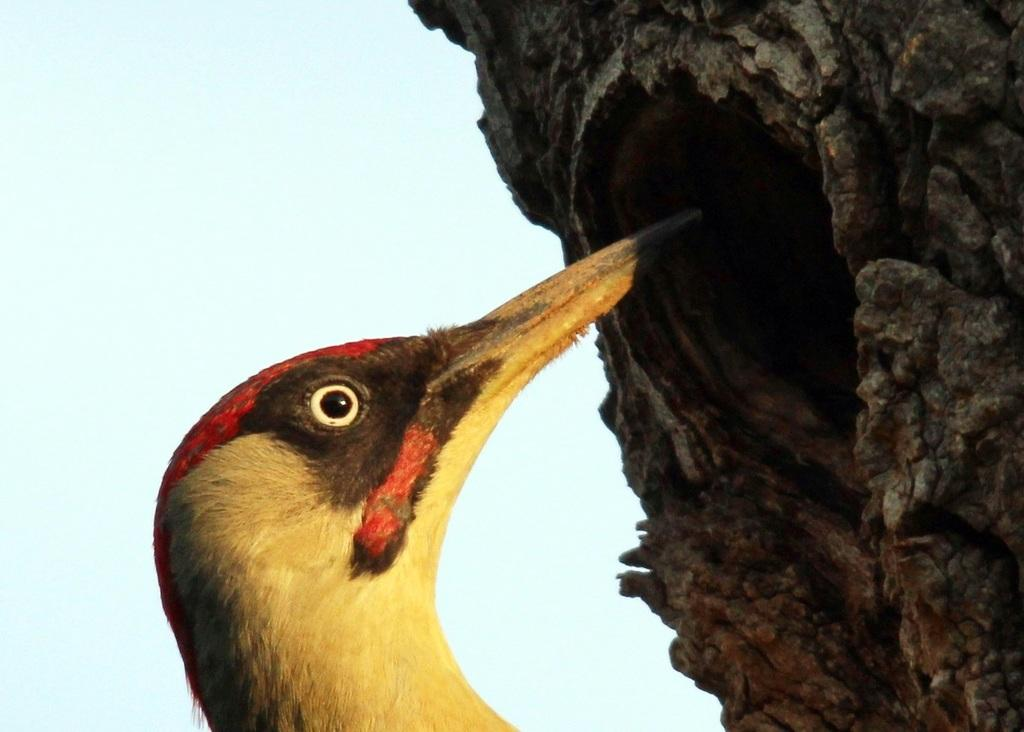What type of animal can be seen in the image? There is a bird in the image. What is the bird perched on in the image? The bird is perched on a tree trunk in the image. What can be seen in the background of the image? The sky is visible in the background of the image. What type of jam is being served in the church in the image? There is no church or jam present in the image; it features a bird perched on a tree trunk with the sky visible in the background. 